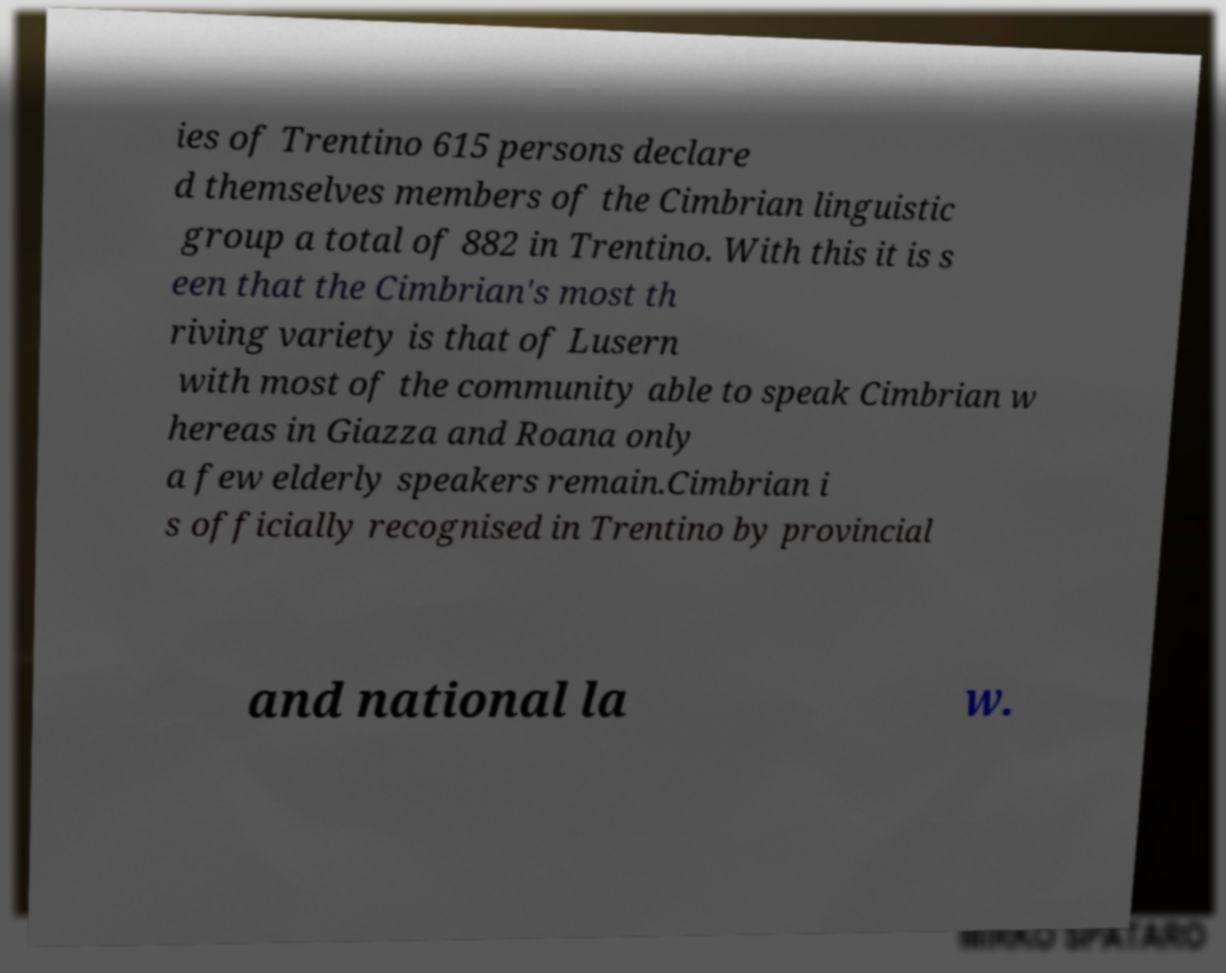What messages or text are displayed in this image? I need them in a readable, typed format. ies of Trentino 615 persons declare d themselves members of the Cimbrian linguistic group a total of 882 in Trentino. With this it is s een that the Cimbrian's most th riving variety is that of Lusern with most of the community able to speak Cimbrian w hereas in Giazza and Roana only a few elderly speakers remain.Cimbrian i s officially recognised in Trentino by provincial and national la w. 